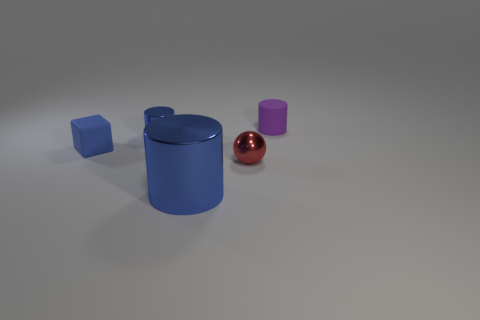Subtract all small matte cylinders. How many cylinders are left? 2 Add 3 big gray matte blocks. How many objects exist? 8 Subtract all purple cylinders. How many cylinders are left? 2 Subtract all cyan blocks. How many blue cylinders are left? 2 Subtract 3 cylinders. How many cylinders are left? 0 Subtract all balls. How many objects are left? 4 Add 5 tiny rubber blocks. How many tiny rubber blocks are left? 6 Add 2 brown rubber spheres. How many brown rubber spheres exist? 2 Subtract 0 green cylinders. How many objects are left? 5 Subtract all yellow cylinders. Subtract all green blocks. How many cylinders are left? 3 